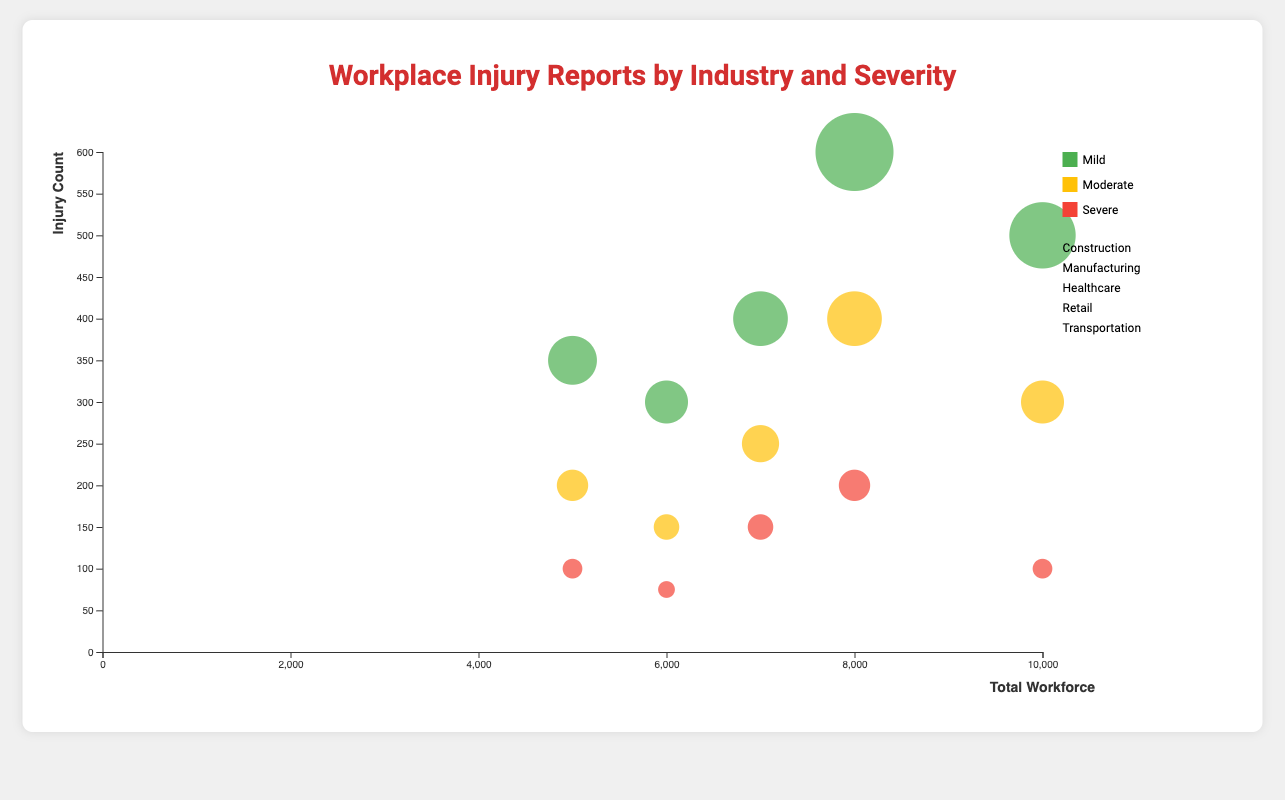How does the distribution of severe injury reports differ between the industries? By looking at the chart, we can observe that for each industry, the severe injury reports are represented by the red bubbles. The largest red bubble is in Retail (200 cases), followed by Manufacturing (150 cases), Healthcare (100 cases), Construction (100 cases), and the smallest in Transportation (75 cases).
Answer: Retail has the most severe injuries and Transportation the least What is the total number of injury reports for Healthcare? The total number of injury reports is the sum of mild (500), moderate (300), and severe (100) injuries for Healthcare. So the calculation is 500 + 300 + 100 = 900.
Answer: 900 Which industry has the mildest injury count in comparison to its workforce size? By examining the size and position of the mild injury (green) bubbles in relation to the workforce size on the x-axis, we can determine that Transportation, with a workforce of 6000 and 300 mild injuries, has the lowest mild injury count relative to its size compared to other industries.
Answer: Transportation What percentage of total injury reports in Manufacturing are severe? We know Manufacturing has 400 mild, 250 moderate, and 150 severe injuries. So the total is 400 + 250 + 150 = 800. The percentage of severe injuries is (150 / 800) * 100 = 18.75%.
Answer: 18.75% How do the injury counts compare between Construction and Retail for severe injuries? By looking at the red bubbles for Construction and Retail on the chart, we can see that Retail has a larger red bubble (200) compared to Construction (100). So, Retail has twice the number of severe injuries as Construction.
Answer: Retail has twice as many severe injuries Which industry has the highest moderate injury count, and how many? By examining the yellow bubbles for moderate injuries, the largest yellow bubble belongs to Retail with 400 moderate injuries.
Answer: Retail, 400 What is the difference in severe injury counts between Retail and Healthcare? Retail has 200 severe injury reports, while Healthcare has 100. The difference is 200 - 100 = 100.
Answer: 100 Is the total workforce larger for Healthcare or Manufacturing? By checking the position on the x-axis for the total workforce, Healthcare is at 10,000 and Manufacturing at 7,000. Therefore, Healthcare has a larger total workforce.
Answer: Healthcare Among all industries, which has the highest mild injury count and what is it? The green bubbles indicate mild injuries. The largest green bubble corresponds to Retail, which has 600 mild injury reports.
Answer: Retail, 600 